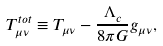<formula> <loc_0><loc_0><loc_500><loc_500>T _ { \mu \nu } ^ { t o t } \equiv T _ { \mu \nu } - \frac { \Lambda _ { c } } { 8 \pi G } g _ { \mu \nu } ,</formula> 